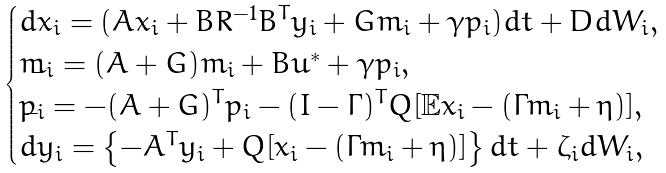Convert formula to latex. <formula><loc_0><loc_0><loc_500><loc_500>\begin{cases} d x _ { i } = ( A x _ { i } + B R ^ { - 1 } B ^ { T } y _ { i } + G m _ { i } + \gamma p _ { i } ) d t + D d W _ { i } , \\ \dot { m _ { i } } = ( A + G ) m _ { i } + B \bar { u } ^ { * } + \gamma p _ { i } , \\ \dot { p _ { i } } = - ( A + G ) ^ { T } p _ { i } - ( I - \Gamma ) ^ { T } Q [ \mathbb { E } x _ { i } - ( \Gamma m _ { i } + \eta ) ] , \\ d y _ { i } = \left \{ - A ^ { T } y _ { i } + Q [ x _ { i } - ( \Gamma m _ { i } + \eta ) ] \right \} d t + \zeta _ { i } d W _ { i } , \end{cases}</formula> 